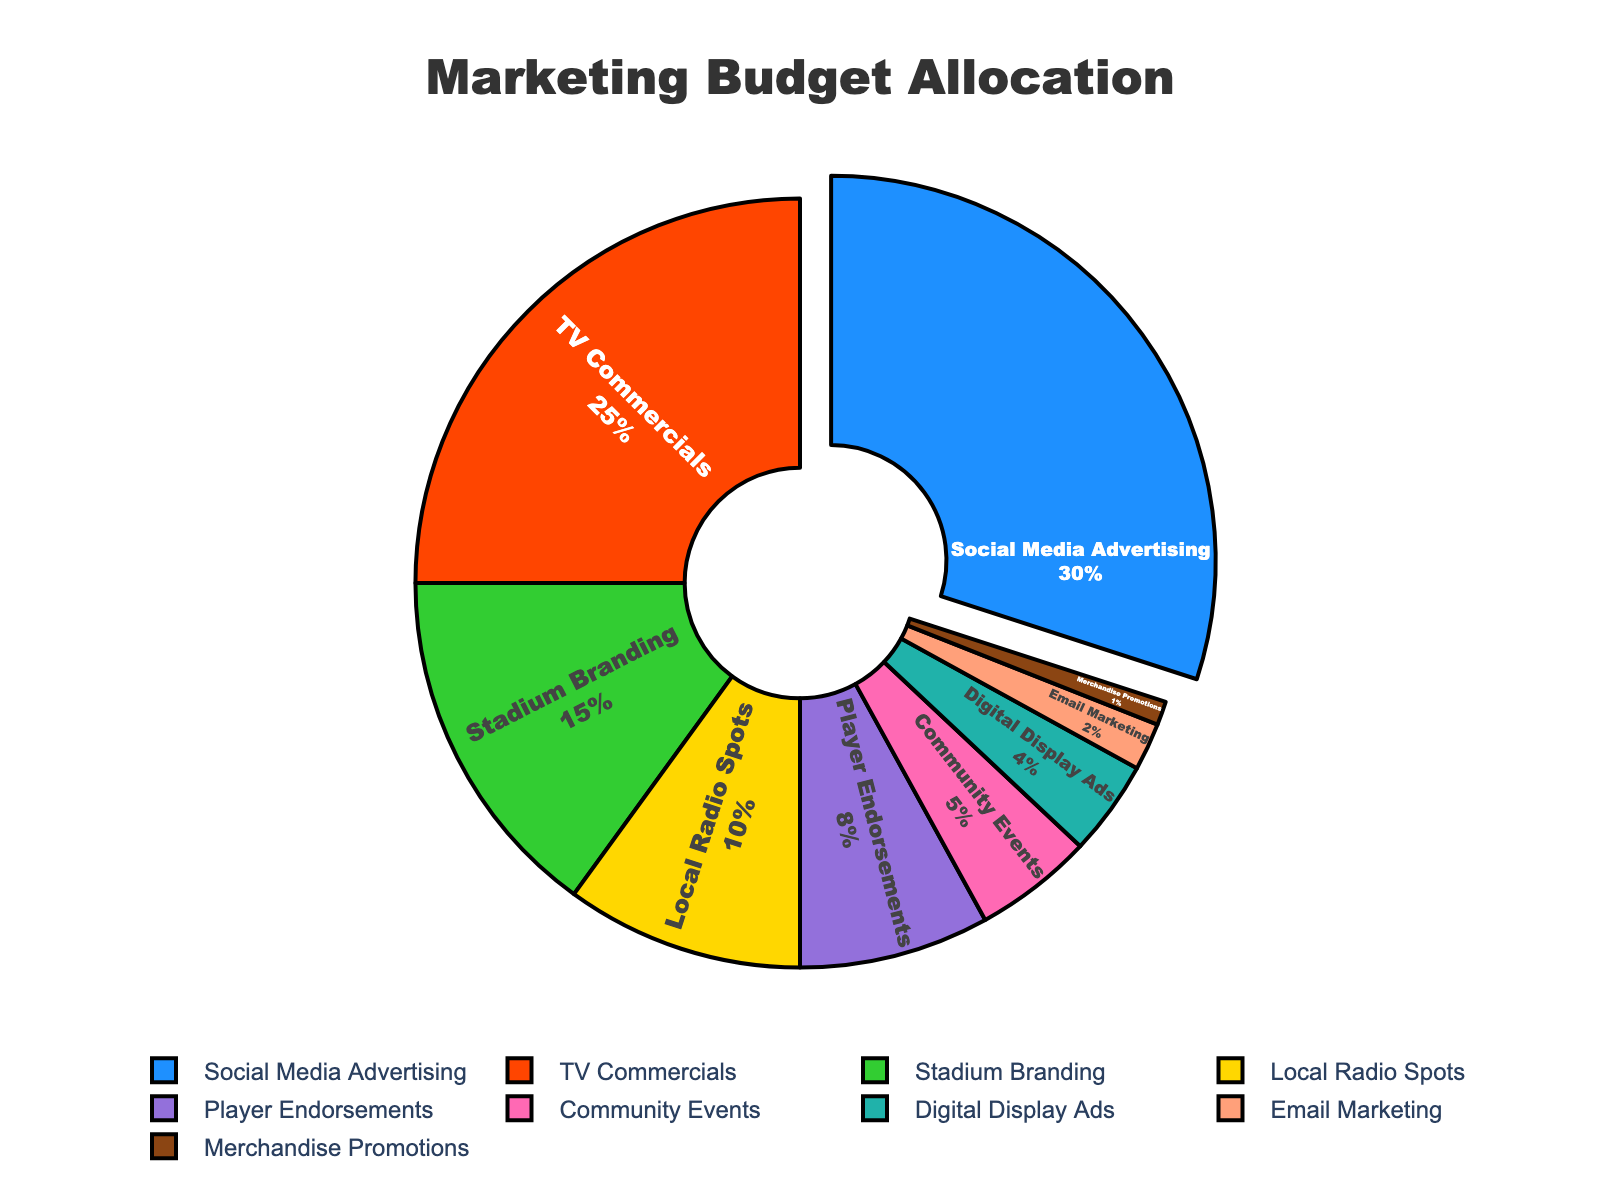Which promotional channel receives the highest marketing budget? The largest section in the pie chart corresponds to Social Media Advertising with a budget allocation of 30%.
Answer: Social Media Advertising Which two channels combined receive a budget allocation equal to or greater than TV Commercials? TV Commercials receive 25%. Combining Stadium Branding (15%) and Local Radio Spots (10%) gives 25%, which is equal.
Answer: Stadium Branding, Local Radio Spots What percentage of the marketing budget is allocated to Digital Display Ads, Email Marketing, and Merchandise Promotions combined? Sum the percentages for Digital Display Ads (4%), Email Marketing (2%), and Merchandise Promotions (1%): 4% + 2% + 1% = 7%
Answer: 7% Which promotional channels have a budget allocation less than 10%? The channels with less than 10% are Local Radio Spots (10%), Player Endorsements (8%), Community Events (5%), Digital Display Ads (4%), Email Marketing (2%), and Merchandise Promotions (1%).
Answer: Player Endorsements, Community Events, Digital Display Ads, Email Marketing, Merchandise Promotions What is the percentage difference between the marketing allocation for Social Media Advertising and TV Commercials? Social Media Advertising is 30% and TV Commercials are 25%. The difference is 30% - 25% = 5%.
Answer: 5% What fraction of the total marketing budget is allocated to Stadium Branding? The percentage for Stadium Branding is 15%. To convert it to a fraction, 15% / 100% = 15/100 = 3/20.
Answer: 3/20 If the budget for TV Commercials is increased by 5%, what will be the total percentage allocation for TV Commercials? Current allocation for TV Commercials is 25%. Increase by 5% would be 25% + 5% = 30%.
Answer: 30% Which channel uses the second largest budget and what is the percentage? The second largest section corresponds to TV Commercials with 25%.
Answer: TV Commercials, 25% Are more resources allocated to Community Events or Player Endorsements? Player Endorsements has 8%, while Community Events has only 5%.
Answer: Player Endorsements 